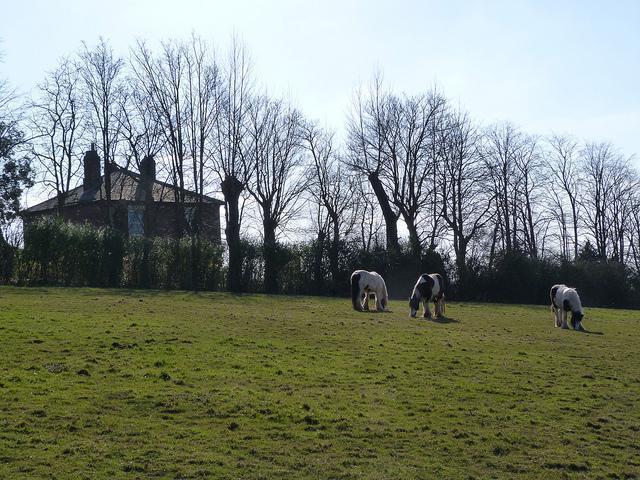How many horses are there?
Give a very brief answer. 3. How many sheep are there?
Give a very brief answer. 0. How many slices of pizza is on the plate?
Give a very brief answer. 0. 